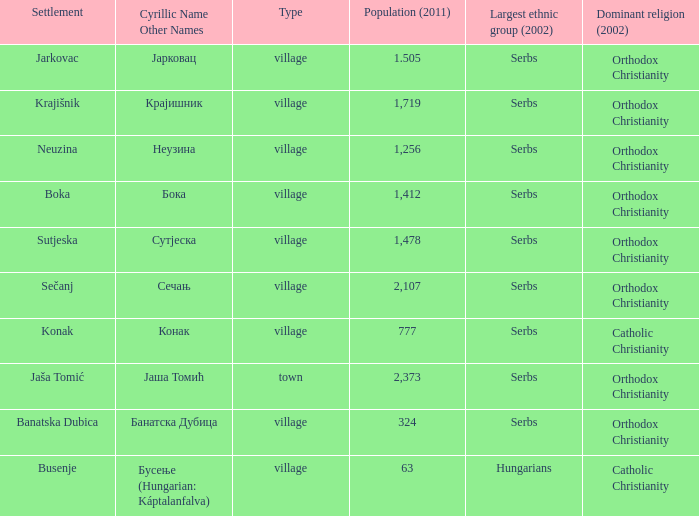The pooulation of јарковац is? 1.505. 